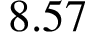Convert formula to latex. <formula><loc_0><loc_0><loc_500><loc_500>8 . 5 7</formula> 